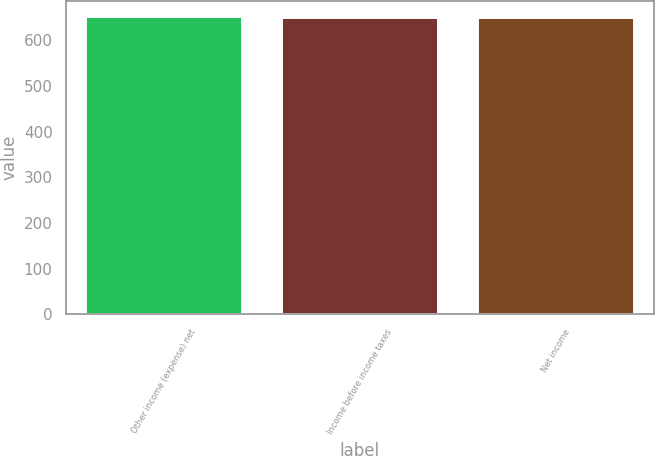<chart> <loc_0><loc_0><loc_500><loc_500><bar_chart><fcel>Other income (expense) net<fcel>Income before income taxes<fcel>Net income<nl><fcel>654<fcel>651<fcel>651.3<nl></chart> 